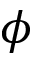<formula> <loc_0><loc_0><loc_500><loc_500>\phi</formula> 